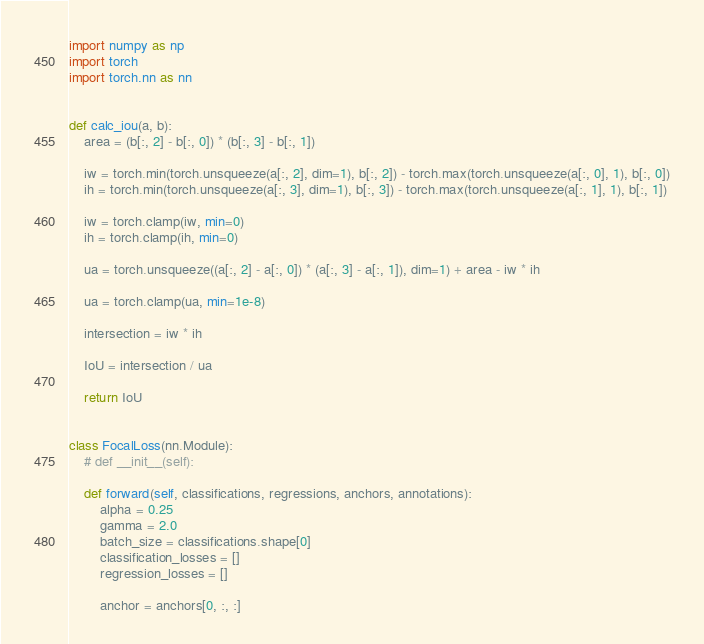<code> <loc_0><loc_0><loc_500><loc_500><_Python_>import numpy as np
import torch
import torch.nn as nn


def calc_iou(a, b):
    area = (b[:, 2] - b[:, 0]) * (b[:, 3] - b[:, 1])

    iw = torch.min(torch.unsqueeze(a[:, 2], dim=1), b[:, 2]) - torch.max(torch.unsqueeze(a[:, 0], 1), b[:, 0])
    ih = torch.min(torch.unsqueeze(a[:, 3], dim=1), b[:, 3]) - torch.max(torch.unsqueeze(a[:, 1], 1), b[:, 1])

    iw = torch.clamp(iw, min=0)
    ih = torch.clamp(ih, min=0)

    ua = torch.unsqueeze((a[:, 2] - a[:, 0]) * (a[:, 3] - a[:, 1]), dim=1) + area - iw * ih

    ua = torch.clamp(ua, min=1e-8)

    intersection = iw * ih

    IoU = intersection / ua

    return IoU


class FocalLoss(nn.Module):
    # def __init__(self):

    def forward(self, classifications, regressions, anchors, annotations):
        alpha = 0.25
        gamma = 2.0
        batch_size = classifications.shape[0]
        classification_losses = []
        regression_losses = []

        anchor = anchors[0, :, :]
</code> 